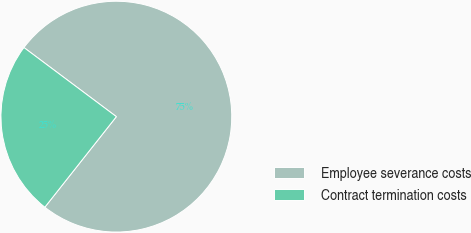Convert chart to OTSL. <chart><loc_0><loc_0><loc_500><loc_500><pie_chart><fcel>Employee severance costs<fcel>Contract termination costs<nl><fcel>75.42%<fcel>24.58%<nl></chart> 